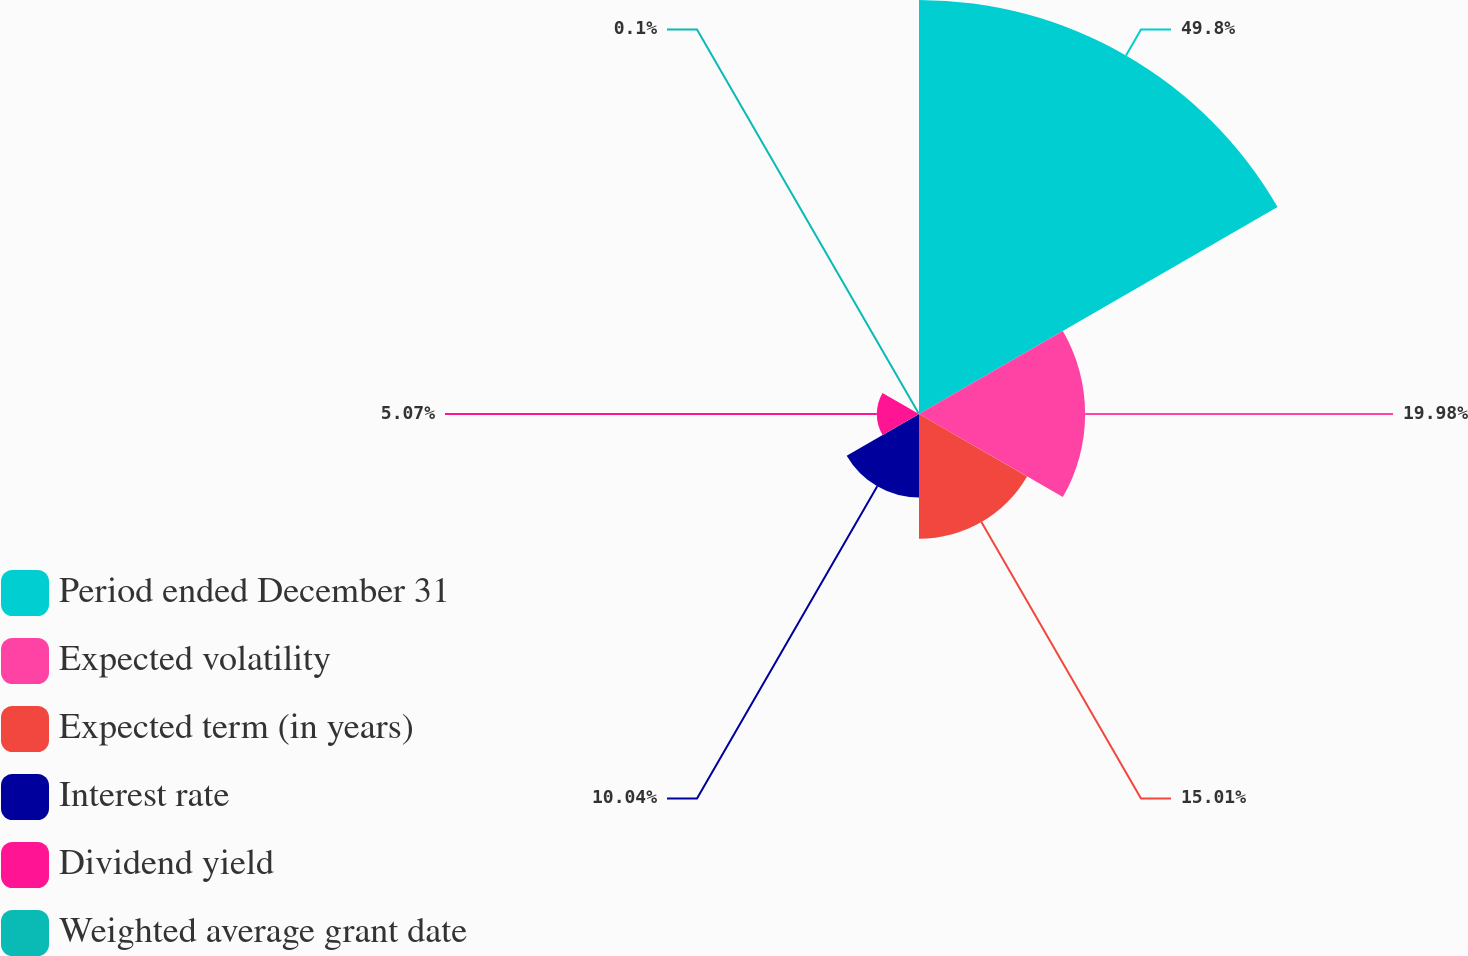Convert chart to OTSL. <chart><loc_0><loc_0><loc_500><loc_500><pie_chart><fcel>Period ended December 31<fcel>Expected volatility<fcel>Expected term (in years)<fcel>Interest rate<fcel>Dividend yield<fcel>Weighted average grant date<nl><fcel>49.79%<fcel>19.98%<fcel>15.01%<fcel>10.04%<fcel>5.07%<fcel>0.1%<nl></chart> 